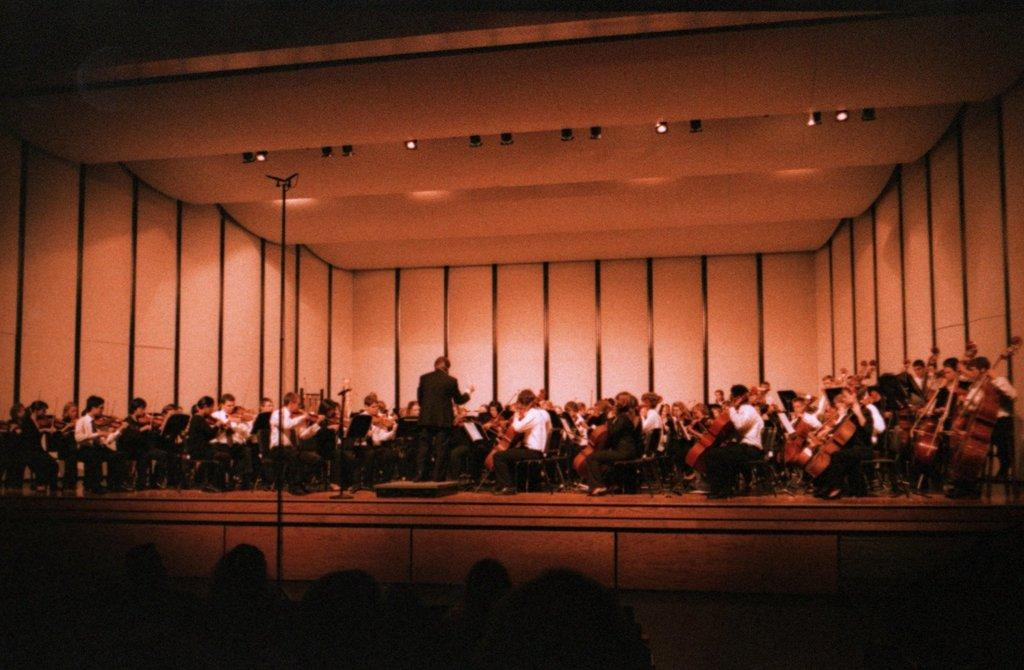What are the people in the image doing while sitting on chairs? Some of the people are playing musical instruments. What can be seen above the people in the image? There is a roof visible in the image. Where are the people located in the image? People are present at the bottom of the image. What type of grain is being used to draw on the pencil in the image? There is no grain or pencil present in the image; the people are playing musical instruments. How does friction affect the sound produced by the musical instruments in the image? The provided facts do not mention any information about friction or its effects on the musical instruments in the image. 